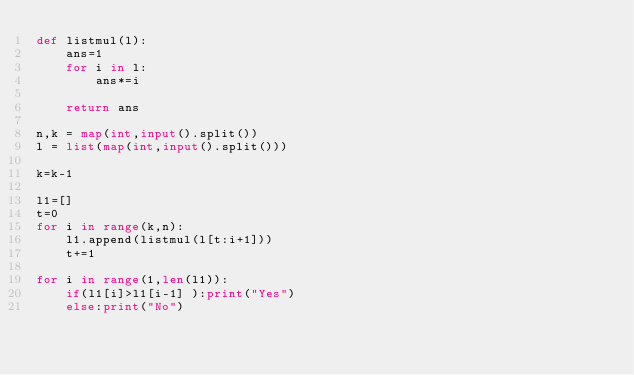Convert code to text. <code><loc_0><loc_0><loc_500><loc_500><_Python_>def listmul(l):
    ans=1
    for i in l:
        ans*=i
        
    return ans

n,k = map(int,input().split())
l = list(map(int,input().split()))

k=k-1

l1=[]
t=0
for i in range(k,n):
    l1.append(listmul(l[t:i+1]))
    t+=1
    
for i in range(1,len(l1)):
    if(l1[i]>l1[i-1] ):print("Yes")
    else:print("No")

    
    </code> 